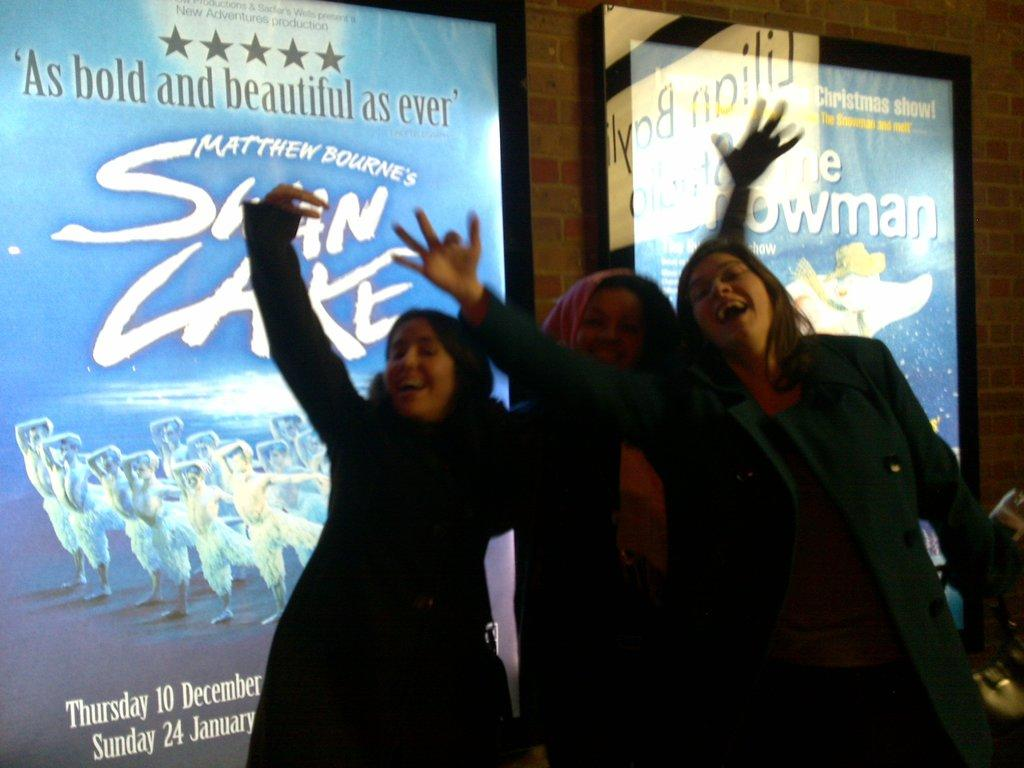Who or what can be seen in the image? There are people in the image. What is on the wall in the image? There is a wall with posters in the image. What can be found on the right side of the image? There are objects on the right side of the image. How many letters are being held by the sheep in the image? There are no sheep present in the image, so it is not possible to determine how many letters they might be holding. 